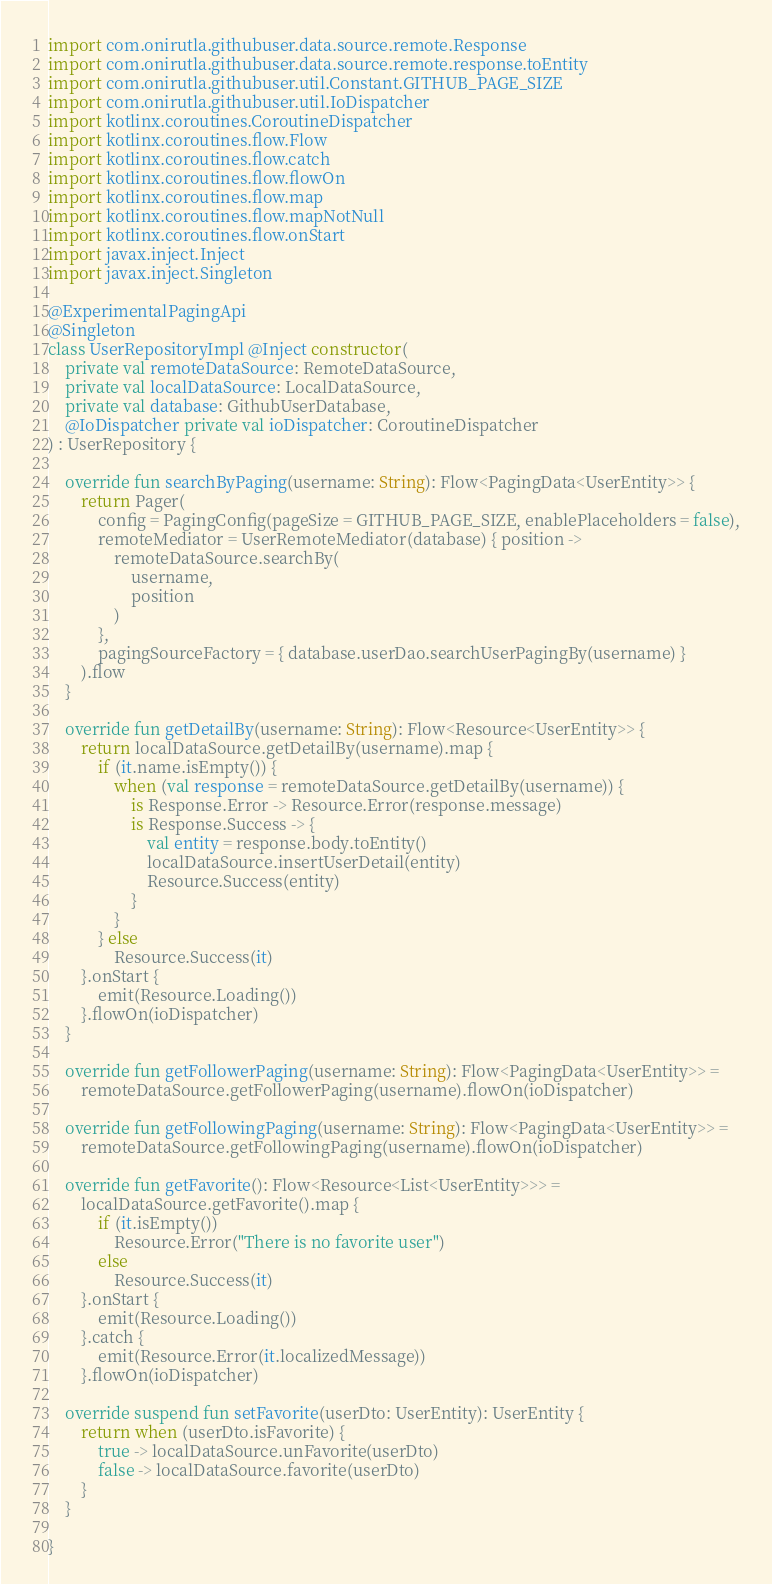Convert code to text. <code><loc_0><loc_0><loc_500><loc_500><_Kotlin_>import com.onirutla.githubuser.data.source.remote.Response
import com.onirutla.githubuser.data.source.remote.response.toEntity
import com.onirutla.githubuser.util.Constant.GITHUB_PAGE_SIZE
import com.onirutla.githubuser.util.IoDispatcher
import kotlinx.coroutines.CoroutineDispatcher
import kotlinx.coroutines.flow.Flow
import kotlinx.coroutines.flow.catch
import kotlinx.coroutines.flow.flowOn
import kotlinx.coroutines.flow.map
import kotlinx.coroutines.flow.mapNotNull
import kotlinx.coroutines.flow.onStart
import javax.inject.Inject
import javax.inject.Singleton

@ExperimentalPagingApi
@Singleton
class UserRepositoryImpl @Inject constructor(
    private val remoteDataSource: RemoteDataSource,
    private val localDataSource: LocalDataSource,
    private val database: GithubUserDatabase,
    @IoDispatcher private val ioDispatcher: CoroutineDispatcher
) : UserRepository {

    override fun searchByPaging(username: String): Flow<PagingData<UserEntity>> {
        return Pager(
            config = PagingConfig(pageSize = GITHUB_PAGE_SIZE, enablePlaceholders = false),
            remoteMediator = UserRemoteMediator(database) { position ->
                remoteDataSource.searchBy(
                    username,
                    position
                )
            },
            pagingSourceFactory = { database.userDao.searchUserPagingBy(username) }
        ).flow
    }

    override fun getDetailBy(username: String): Flow<Resource<UserEntity>> {
        return localDataSource.getDetailBy(username).map {
            if (it.name.isEmpty()) {
                when (val response = remoteDataSource.getDetailBy(username)) {
                    is Response.Error -> Resource.Error(response.message)
                    is Response.Success -> {
                        val entity = response.body.toEntity()
                        localDataSource.insertUserDetail(entity)
                        Resource.Success(entity)
                    }
                }
            } else
                Resource.Success(it)
        }.onStart {
            emit(Resource.Loading())
        }.flowOn(ioDispatcher)
    }

    override fun getFollowerPaging(username: String): Flow<PagingData<UserEntity>> =
        remoteDataSource.getFollowerPaging(username).flowOn(ioDispatcher)

    override fun getFollowingPaging(username: String): Flow<PagingData<UserEntity>> =
        remoteDataSource.getFollowingPaging(username).flowOn(ioDispatcher)

    override fun getFavorite(): Flow<Resource<List<UserEntity>>> =
        localDataSource.getFavorite().map {
            if (it.isEmpty())
                Resource.Error("There is no favorite user")
            else
                Resource.Success(it)
        }.onStart {
            emit(Resource.Loading())
        }.catch {
            emit(Resource.Error(it.localizedMessage))
        }.flowOn(ioDispatcher)

    override suspend fun setFavorite(userDto: UserEntity): UserEntity {
        return when (userDto.isFavorite) {
            true -> localDataSource.unFavorite(userDto)
            false -> localDataSource.favorite(userDto)
        }
    }

}
</code> 